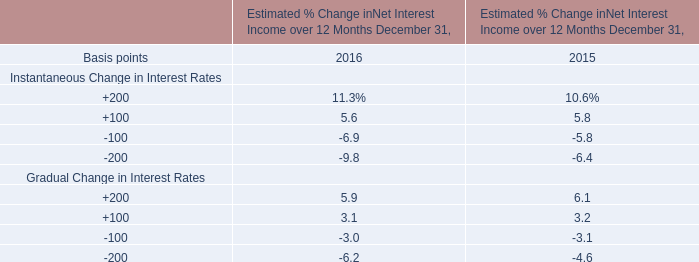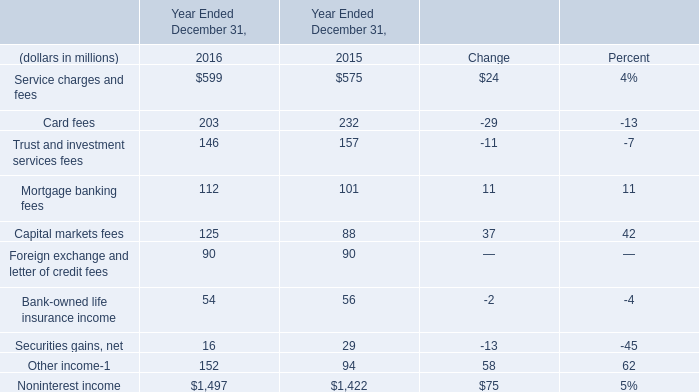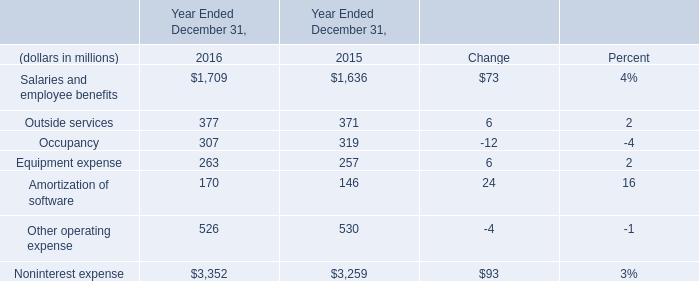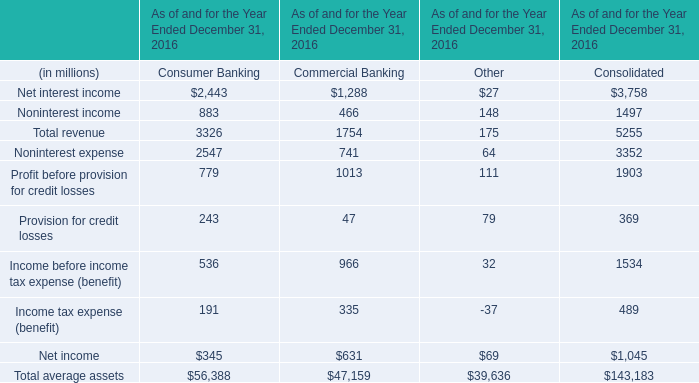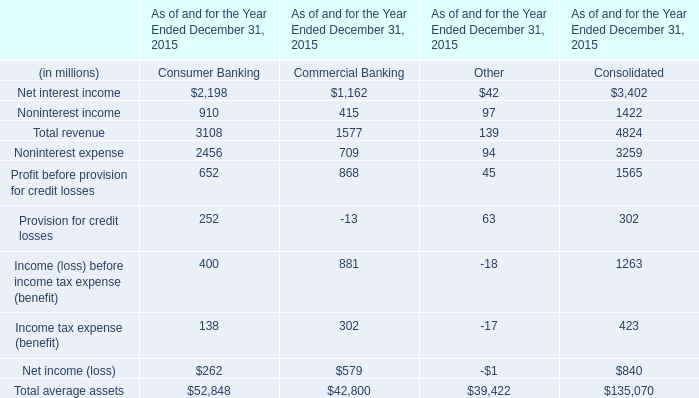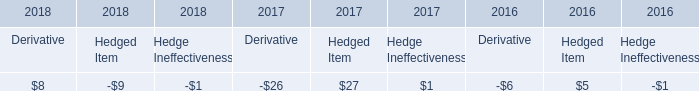what was the company market capitalization on august 15 , 2019, 
Computations: (145300 * 141.94)
Answer: 20623882.0. 